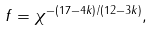<formula> <loc_0><loc_0><loc_500><loc_500>f = \chi ^ { - ( 1 7 - 4 k ) / ( 1 2 - 3 k ) } ,</formula> 